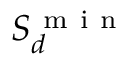Convert formula to latex. <formula><loc_0><loc_0><loc_500><loc_500>S _ { d } ^ { m i n }</formula> 